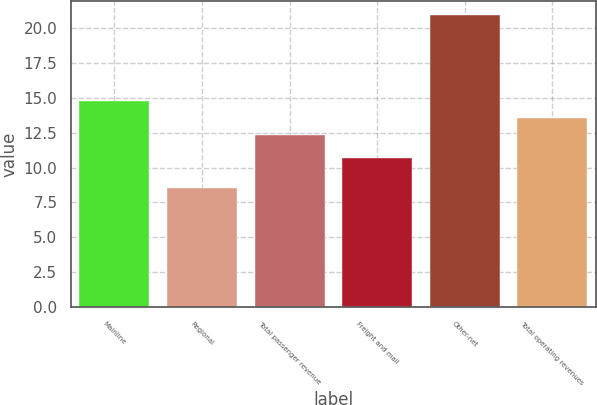Convert chart. <chart><loc_0><loc_0><loc_500><loc_500><bar_chart><fcel>Mainline<fcel>Regional<fcel>Total passenger revenue<fcel>Freight and mail<fcel>Other-net<fcel>Total operating revenues<nl><fcel>14.78<fcel>8.5<fcel>12.3<fcel>10.7<fcel>20.9<fcel>13.54<nl></chart> 